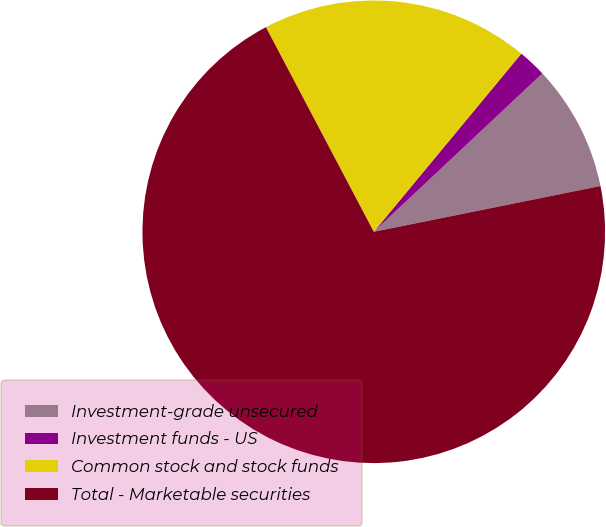Convert chart to OTSL. <chart><loc_0><loc_0><loc_500><loc_500><pie_chart><fcel>Investment-grade unsecured<fcel>Investment funds - US<fcel>Common stock and stock funds<fcel>Total - Marketable securities<nl><fcel>8.83%<fcel>1.99%<fcel>18.73%<fcel>70.45%<nl></chart> 